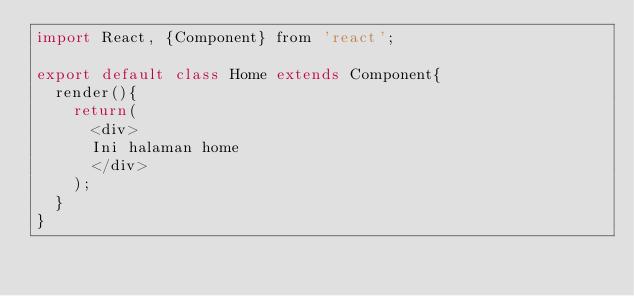Convert code to text. <code><loc_0><loc_0><loc_500><loc_500><_JavaScript_>import React, {Component} from 'react';

export default class Home extends Component{
  render(){
    return(
      <div>
      Ini halaman home
      </div>
    );
  }
}
</code> 